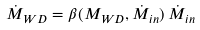<formula> <loc_0><loc_0><loc_500><loc_500>\dot { M } _ { W D } = \beta ( M _ { W D } , \dot { M } _ { i n } ) \, \dot { M } _ { i n }</formula> 